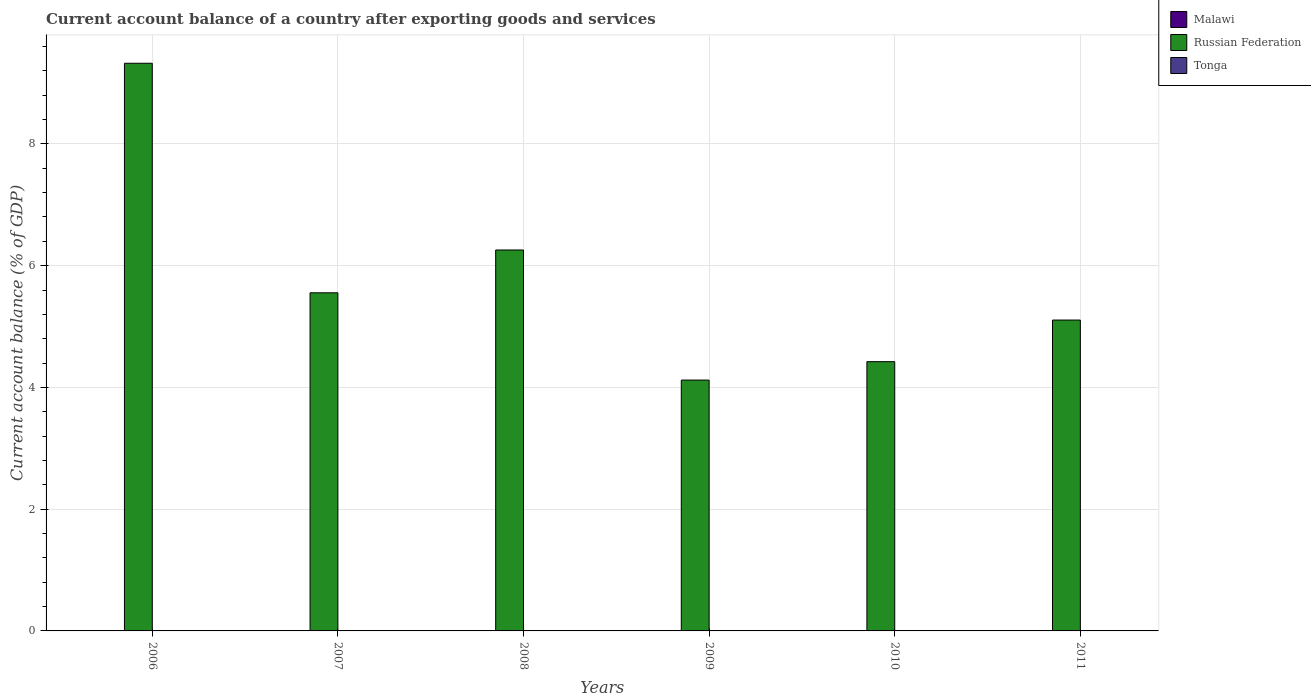How many different coloured bars are there?
Your response must be concise. 1. How many bars are there on the 5th tick from the left?
Your answer should be compact. 1. How many bars are there on the 2nd tick from the right?
Keep it short and to the point. 1. Across all years, what is the maximum account balance in Russian Federation?
Ensure brevity in your answer.  9.33. What is the difference between the account balance in Russian Federation in 2007 and that in 2009?
Provide a succinct answer. 1.43. What is the average account balance in Russian Federation per year?
Your answer should be compact. 5.8. In how many years, is the account balance in Russian Federation greater than 6.8 %?
Provide a short and direct response. 1. Is the account balance in Russian Federation in 2006 less than that in 2010?
Your response must be concise. No. What is the difference between the highest and the second highest account balance in Russian Federation?
Give a very brief answer. 3.07. What is the difference between the highest and the lowest account balance in Russian Federation?
Offer a very short reply. 5.2. How many bars are there?
Ensure brevity in your answer.  6. Are all the bars in the graph horizontal?
Your answer should be very brief. No. How many years are there in the graph?
Make the answer very short. 6. Are the values on the major ticks of Y-axis written in scientific E-notation?
Give a very brief answer. No. Does the graph contain grids?
Your answer should be compact. Yes. Where does the legend appear in the graph?
Your answer should be very brief. Top right. What is the title of the graph?
Ensure brevity in your answer.  Current account balance of a country after exporting goods and services. Does "Mauritania" appear as one of the legend labels in the graph?
Your answer should be very brief. No. What is the label or title of the X-axis?
Give a very brief answer. Years. What is the label or title of the Y-axis?
Give a very brief answer. Current account balance (% of GDP). What is the Current account balance (% of GDP) of Russian Federation in 2006?
Ensure brevity in your answer.  9.33. What is the Current account balance (% of GDP) of Russian Federation in 2007?
Keep it short and to the point. 5.55. What is the Current account balance (% of GDP) in Malawi in 2008?
Provide a short and direct response. 0. What is the Current account balance (% of GDP) of Russian Federation in 2008?
Your response must be concise. 6.26. What is the Current account balance (% of GDP) in Tonga in 2008?
Provide a short and direct response. 0. What is the Current account balance (% of GDP) of Russian Federation in 2009?
Ensure brevity in your answer.  4.12. What is the Current account balance (% of GDP) of Malawi in 2010?
Give a very brief answer. 0. What is the Current account balance (% of GDP) in Russian Federation in 2010?
Ensure brevity in your answer.  4.42. What is the Current account balance (% of GDP) of Tonga in 2010?
Ensure brevity in your answer.  0. What is the Current account balance (% of GDP) of Russian Federation in 2011?
Your answer should be very brief. 5.11. What is the Current account balance (% of GDP) in Tonga in 2011?
Ensure brevity in your answer.  0. Across all years, what is the maximum Current account balance (% of GDP) in Russian Federation?
Give a very brief answer. 9.33. Across all years, what is the minimum Current account balance (% of GDP) of Russian Federation?
Offer a terse response. 4.12. What is the total Current account balance (% of GDP) in Russian Federation in the graph?
Provide a short and direct response. 34.79. What is the total Current account balance (% of GDP) in Tonga in the graph?
Offer a very short reply. 0. What is the difference between the Current account balance (% of GDP) of Russian Federation in 2006 and that in 2007?
Your answer should be very brief. 3.77. What is the difference between the Current account balance (% of GDP) in Russian Federation in 2006 and that in 2008?
Provide a succinct answer. 3.07. What is the difference between the Current account balance (% of GDP) in Russian Federation in 2006 and that in 2009?
Your answer should be very brief. 5.2. What is the difference between the Current account balance (% of GDP) in Russian Federation in 2006 and that in 2010?
Provide a short and direct response. 4.9. What is the difference between the Current account balance (% of GDP) in Russian Federation in 2006 and that in 2011?
Make the answer very short. 4.22. What is the difference between the Current account balance (% of GDP) in Russian Federation in 2007 and that in 2008?
Your answer should be compact. -0.7. What is the difference between the Current account balance (% of GDP) in Russian Federation in 2007 and that in 2009?
Keep it short and to the point. 1.43. What is the difference between the Current account balance (% of GDP) in Russian Federation in 2007 and that in 2010?
Provide a succinct answer. 1.13. What is the difference between the Current account balance (% of GDP) of Russian Federation in 2007 and that in 2011?
Make the answer very short. 0.45. What is the difference between the Current account balance (% of GDP) in Russian Federation in 2008 and that in 2009?
Your answer should be compact. 2.14. What is the difference between the Current account balance (% of GDP) of Russian Federation in 2008 and that in 2010?
Give a very brief answer. 1.83. What is the difference between the Current account balance (% of GDP) of Russian Federation in 2008 and that in 2011?
Give a very brief answer. 1.15. What is the difference between the Current account balance (% of GDP) of Russian Federation in 2009 and that in 2010?
Give a very brief answer. -0.3. What is the difference between the Current account balance (% of GDP) of Russian Federation in 2009 and that in 2011?
Your response must be concise. -0.99. What is the difference between the Current account balance (% of GDP) in Russian Federation in 2010 and that in 2011?
Make the answer very short. -0.68. What is the average Current account balance (% of GDP) in Malawi per year?
Give a very brief answer. 0. What is the average Current account balance (% of GDP) of Russian Federation per year?
Keep it short and to the point. 5.8. What is the ratio of the Current account balance (% of GDP) in Russian Federation in 2006 to that in 2007?
Make the answer very short. 1.68. What is the ratio of the Current account balance (% of GDP) in Russian Federation in 2006 to that in 2008?
Give a very brief answer. 1.49. What is the ratio of the Current account balance (% of GDP) of Russian Federation in 2006 to that in 2009?
Give a very brief answer. 2.26. What is the ratio of the Current account balance (% of GDP) of Russian Federation in 2006 to that in 2010?
Your response must be concise. 2.11. What is the ratio of the Current account balance (% of GDP) in Russian Federation in 2006 to that in 2011?
Your answer should be very brief. 1.83. What is the ratio of the Current account balance (% of GDP) of Russian Federation in 2007 to that in 2008?
Offer a very short reply. 0.89. What is the ratio of the Current account balance (% of GDP) of Russian Federation in 2007 to that in 2009?
Offer a terse response. 1.35. What is the ratio of the Current account balance (% of GDP) in Russian Federation in 2007 to that in 2010?
Offer a terse response. 1.26. What is the ratio of the Current account balance (% of GDP) of Russian Federation in 2007 to that in 2011?
Give a very brief answer. 1.09. What is the ratio of the Current account balance (% of GDP) of Russian Federation in 2008 to that in 2009?
Your response must be concise. 1.52. What is the ratio of the Current account balance (% of GDP) of Russian Federation in 2008 to that in 2010?
Offer a very short reply. 1.41. What is the ratio of the Current account balance (% of GDP) of Russian Federation in 2008 to that in 2011?
Your response must be concise. 1.23. What is the ratio of the Current account balance (% of GDP) of Russian Federation in 2009 to that in 2010?
Your response must be concise. 0.93. What is the ratio of the Current account balance (% of GDP) in Russian Federation in 2009 to that in 2011?
Offer a very short reply. 0.81. What is the ratio of the Current account balance (% of GDP) of Russian Federation in 2010 to that in 2011?
Make the answer very short. 0.87. What is the difference between the highest and the second highest Current account balance (% of GDP) in Russian Federation?
Make the answer very short. 3.07. What is the difference between the highest and the lowest Current account balance (% of GDP) of Russian Federation?
Offer a very short reply. 5.2. 